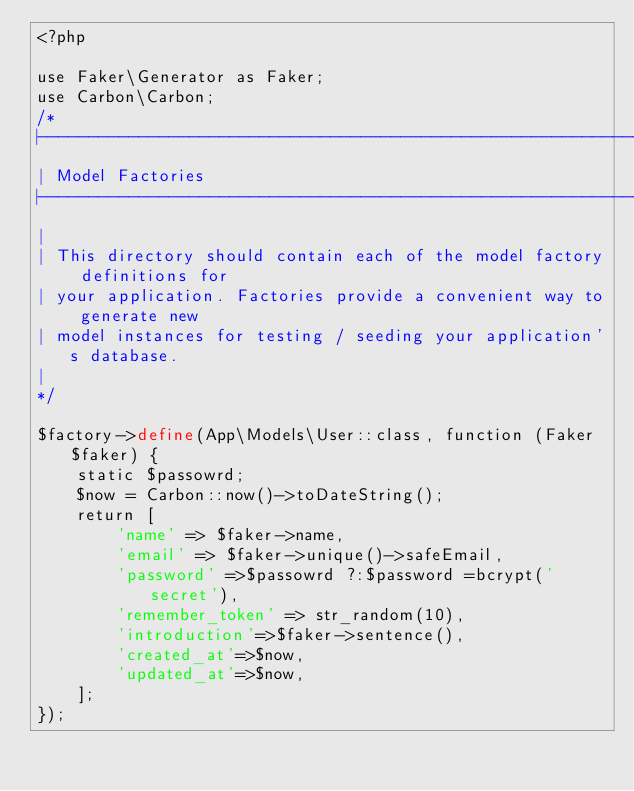Convert code to text. <code><loc_0><loc_0><loc_500><loc_500><_PHP_><?php

use Faker\Generator as Faker;
use Carbon\Carbon;
/*
|--------------------------------------------------------------------------
| Model Factories
|--------------------------------------------------------------------------
|
| This directory should contain each of the model factory definitions for
| your application. Factories provide a convenient way to generate new
| model instances for testing / seeding your application's database.
|
*/

$factory->define(App\Models\User::class, function (Faker $faker) {
    static $passowrd;
    $now = Carbon::now()->toDateString();
    return [
        'name' => $faker->name,
        'email' => $faker->unique()->safeEmail,
        'password' =>$passowrd ?:$password =bcrypt('secret'),
        'remember_token' => str_random(10),
        'introduction'=>$faker->sentence(),
        'created_at'=>$now,
        'updated_at'=>$now,
    ];
});
</code> 